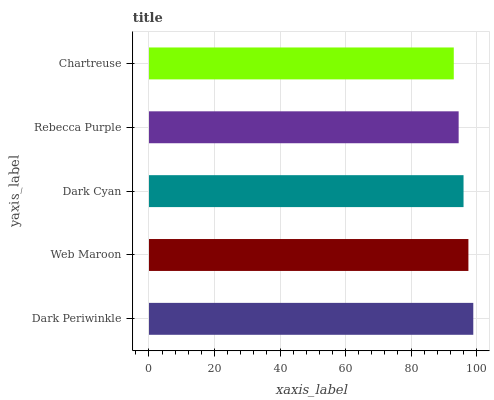Is Chartreuse the minimum?
Answer yes or no. Yes. Is Dark Periwinkle the maximum?
Answer yes or no. Yes. Is Web Maroon the minimum?
Answer yes or no. No. Is Web Maroon the maximum?
Answer yes or no. No. Is Dark Periwinkle greater than Web Maroon?
Answer yes or no. Yes. Is Web Maroon less than Dark Periwinkle?
Answer yes or no. Yes. Is Web Maroon greater than Dark Periwinkle?
Answer yes or no. No. Is Dark Periwinkle less than Web Maroon?
Answer yes or no. No. Is Dark Cyan the high median?
Answer yes or no. Yes. Is Dark Cyan the low median?
Answer yes or no. Yes. Is Rebecca Purple the high median?
Answer yes or no. No. Is Web Maroon the low median?
Answer yes or no. No. 